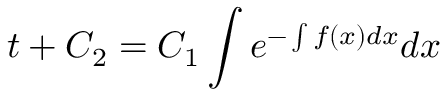Convert formula to latex. <formula><loc_0><loc_0><loc_500><loc_500>t + C _ { 2 } = C _ { 1 } \int e ^ { - \int f ( x ) d x } d x</formula> 